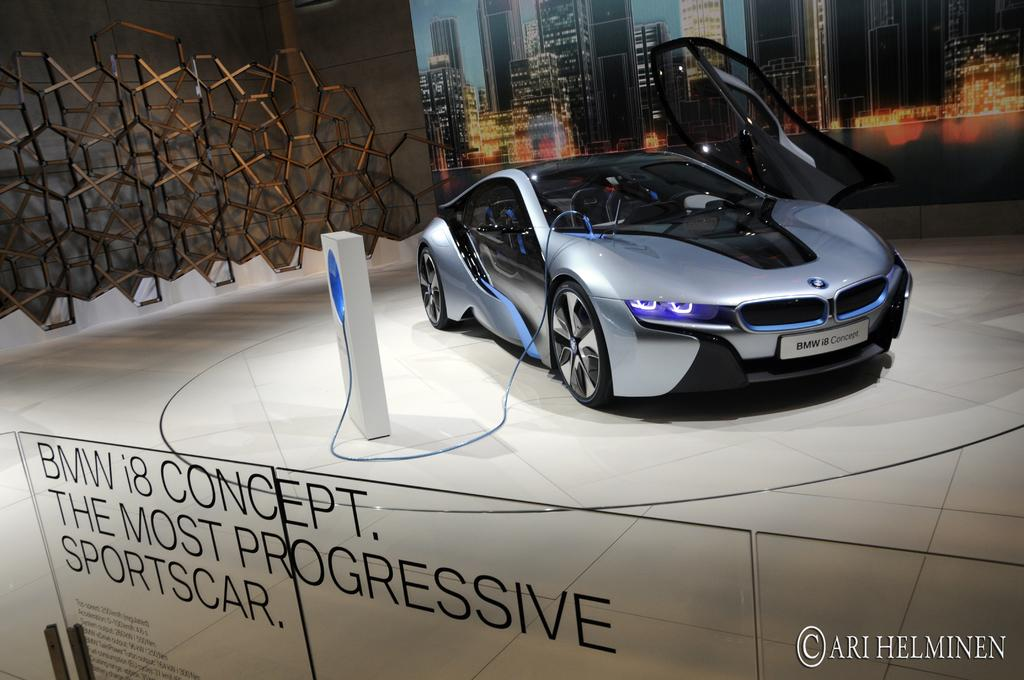What is the main subject of the image? There is a car in the image. What is located at the bottom of the image? There is a glass board at the bottom of the image. What can be seen in the background of the image? There is a wall in the background of the image. What is on the wall in the background? There is a poster on the wall in the background. What type of mountain can be seen in the background of the image? There is no mountain visible in the image; it features a car, a glass board, a wall, and a poster. What color is the silver point on the poster? There is no silver point mentioned on the poster, and the color of any point cannot be determined from the image. 